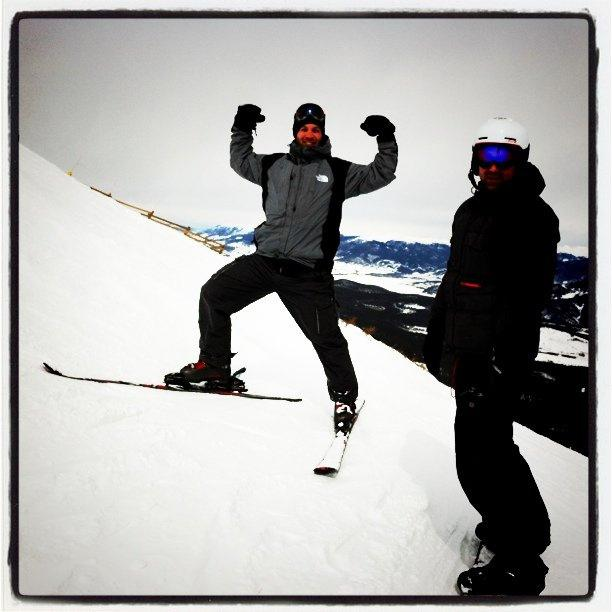What muscles in the male showing off? biceps 